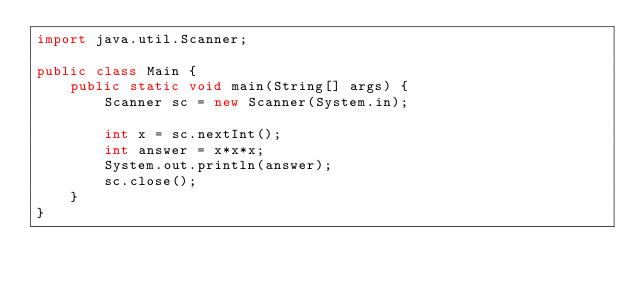Convert code to text. <code><loc_0><loc_0><loc_500><loc_500><_Java_>import java.util.Scanner;

public class Main {
    public static void main(String[] args) {
        Scanner sc = new Scanner(System.in);

        int x = sc.nextInt();
        int answer = x*x*x;
        System.out.println(answer);
        sc.close();
    }
}
</code> 